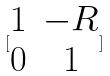Convert formula to latex. <formula><loc_0><loc_0><loc_500><loc_500>[ \begin{matrix} 1 & - R \\ 0 & 1 \end{matrix} ]</formula> 